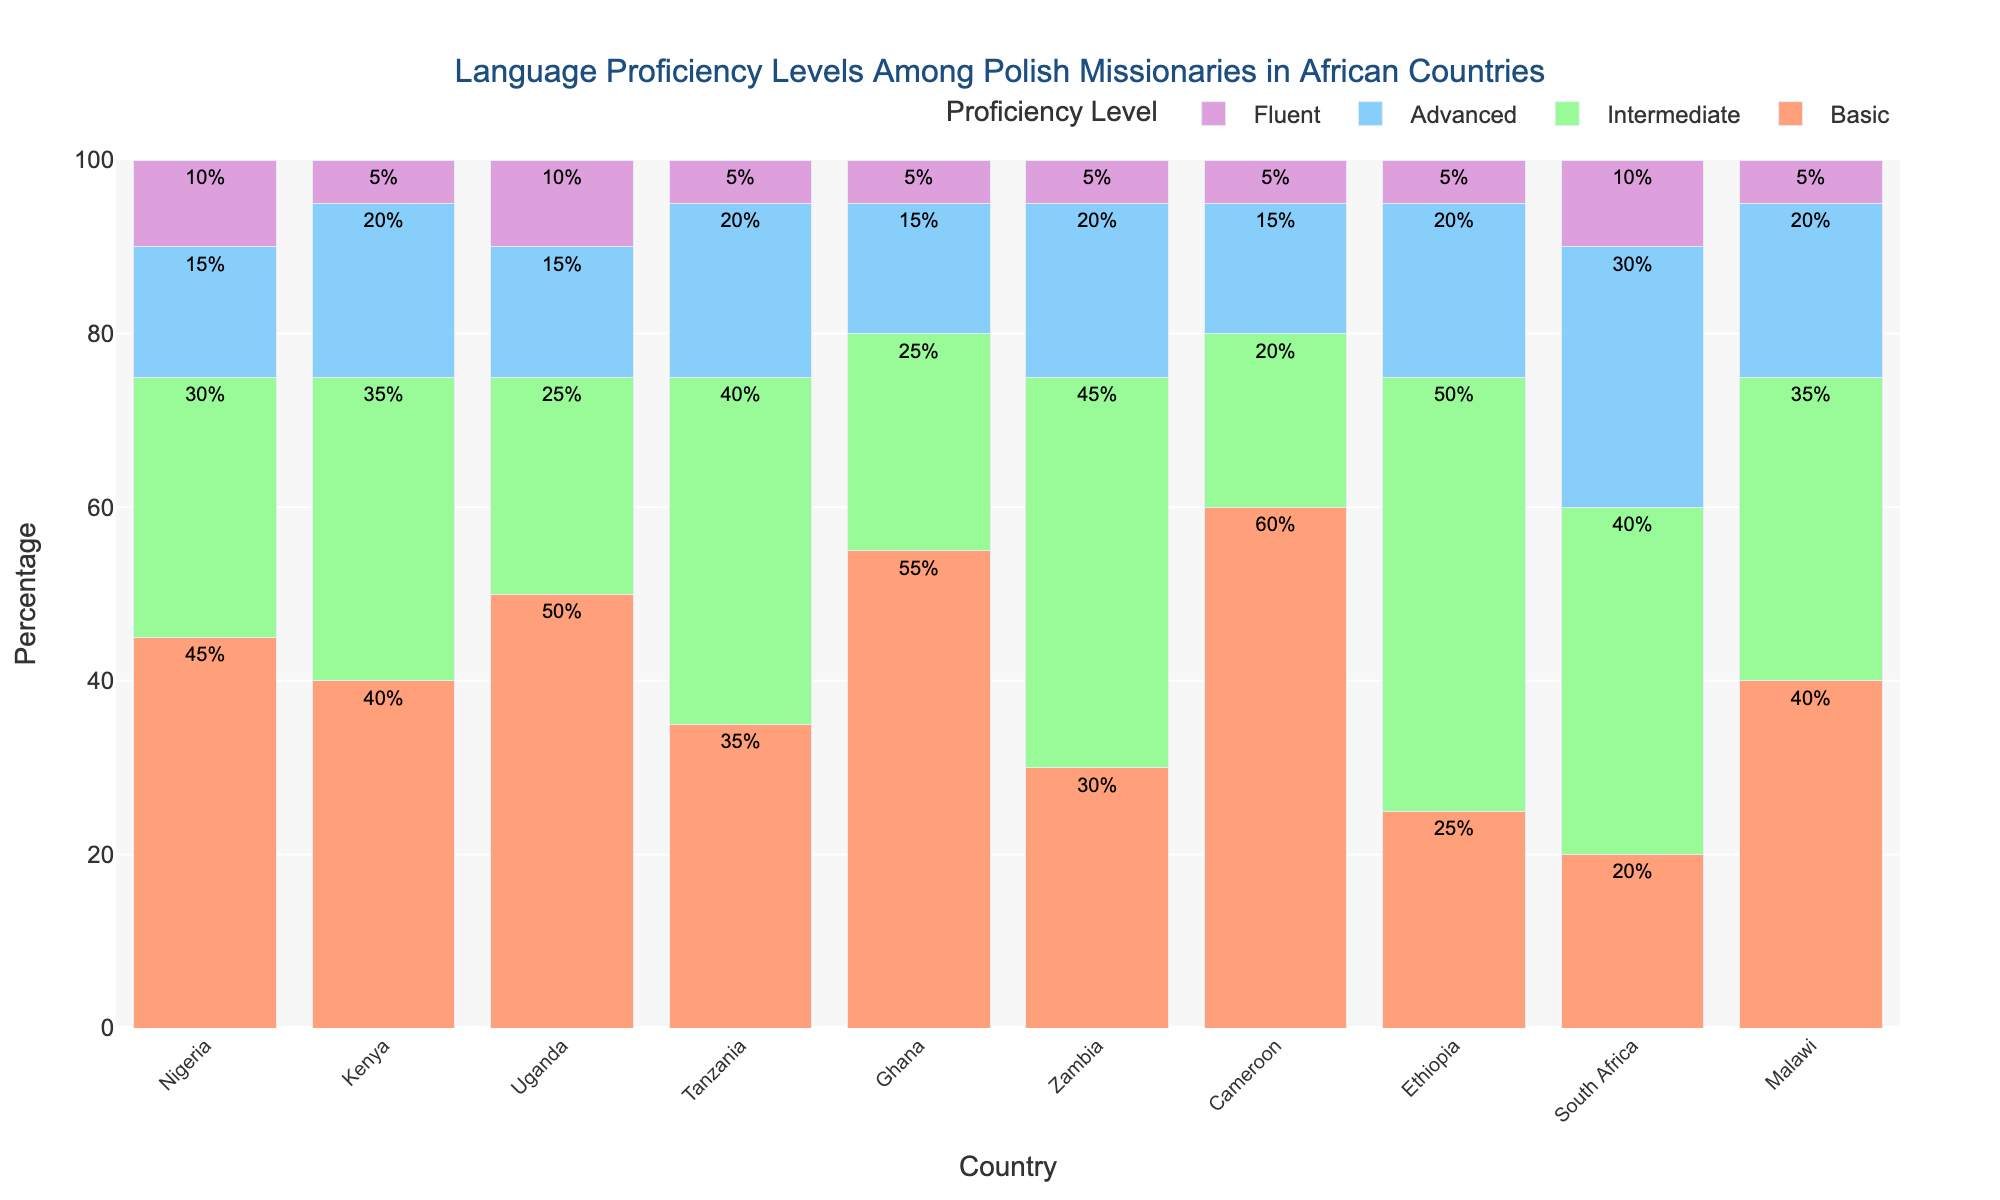Which country has the highest percentage of missionaries with basic proficiency? To determine this, look at the height of the bars labeled "Basic" for each country. The highest bar under the "Basic" category represents the country with the highest percentage.
Answer: Cameroon What is the combined percentage of missionaries with advanced and fluent proficiency in Ethiopia? Add the percentages for "Advanced" and "Fluent" in the Ethiopia row. Advanced is 20%, and Fluent is 5%, so 20% + 5% = 25%.
Answer: 25% Which country has the smallest percentage of missionaries with intermediate proficiency? Compare the height of the "Intermediate" bars for all countries and identify the shortest one.
Answer: Cameroon How does the percentage of fluent missionaries in South Africa compare to that in Nigeria? Compare the height of the "Fluent" bar for South Africa with that of Nigeria. Both percentages are relatively visible.
Answer: Equal What's the difference in the percentage of missionaries with intermediate proficiency between Kenya and Uganda? Subtract the percentage of "Intermediate" proficiency missionaries in Uganda (25%) from that in Kenya (35%). 35% - 25% = 10%
Answer: 10% Which countries have the same percentage of missionaries with basic proficiency? Look for bars of "Basic" proficiency that are of equal height. Compare the heights and identify the countries.
Answer: Kenya and Malawi What is the average percentage of missionaries with fluent proficiency across all countries? Add the fluent percentages for all countries (10+5+10+5+5+5+5+5+10+5 = 65%) and divide by the number of countries (10). 65/10 = 6.5%
Answer: 6.5% Which country has the largest percentage difference between basic and intermediate proficiency levels? Calculate the difference between basic and intermediate proficiency for each country, and identify the country with the largest difference. Example: For Ethiopia, the difference is 50% - 25% = 25%; for Nigeria, it's 45% - 30% = 15%. Continue for all countries and identify the largest difference.
Answer: Ethiopia 